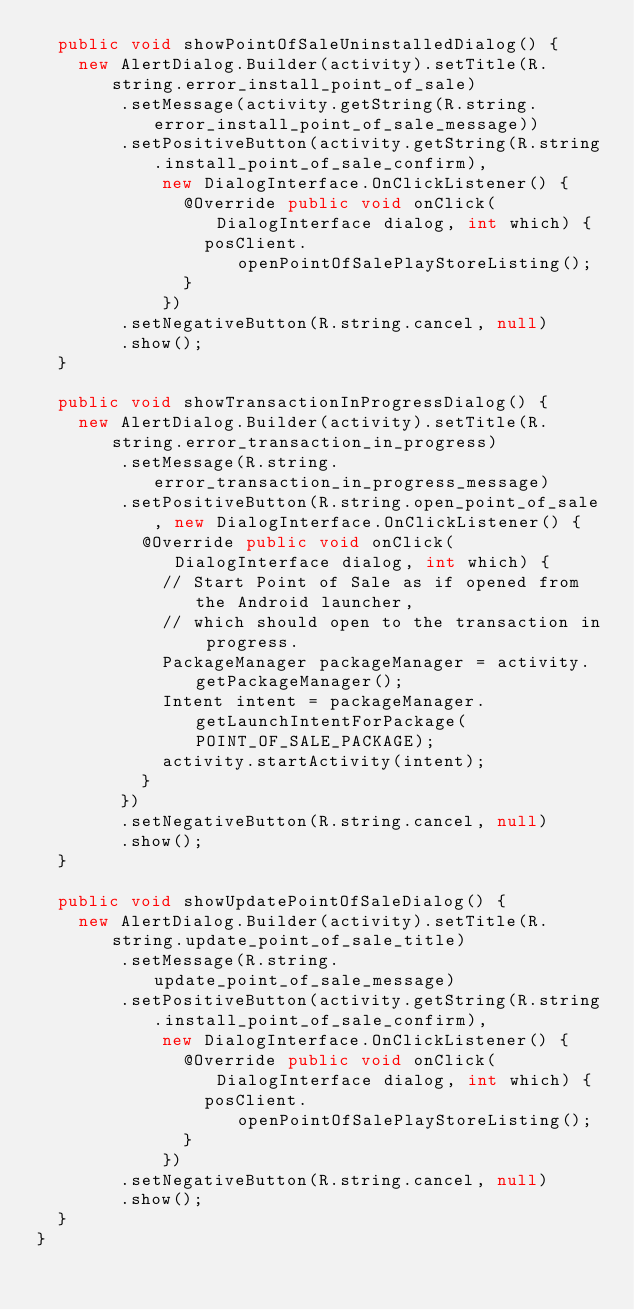Convert code to text. <code><loc_0><loc_0><loc_500><loc_500><_Java_>  public void showPointOfSaleUninstalledDialog() {
    new AlertDialog.Builder(activity).setTitle(R.string.error_install_point_of_sale)
        .setMessage(activity.getString(R.string.error_install_point_of_sale_message))
        .setPositiveButton(activity.getString(R.string.install_point_of_sale_confirm),
            new DialogInterface.OnClickListener() {
              @Override public void onClick(DialogInterface dialog, int which) {
                posClient.openPointOfSalePlayStoreListing();
              }
            })
        .setNegativeButton(R.string.cancel, null)
        .show();
  }

  public void showTransactionInProgressDialog() {
    new AlertDialog.Builder(activity).setTitle(R.string.error_transaction_in_progress)
        .setMessage(R.string.error_transaction_in_progress_message)
        .setPositiveButton(R.string.open_point_of_sale, new DialogInterface.OnClickListener() {
          @Override public void onClick(DialogInterface dialog, int which) {
            // Start Point of Sale as if opened from the Android launcher,
            // which should open to the transaction in progress.
            PackageManager packageManager = activity.getPackageManager();
            Intent intent = packageManager.getLaunchIntentForPackage(POINT_OF_SALE_PACKAGE);
            activity.startActivity(intent);
          }
        })
        .setNegativeButton(R.string.cancel, null)
        .show();
  }

  public void showUpdatePointOfSaleDialog() {
    new AlertDialog.Builder(activity).setTitle(R.string.update_point_of_sale_title)
        .setMessage(R.string.update_point_of_sale_message)
        .setPositiveButton(activity.getString(R.string.install_point_of_sale_confirm),
            new DialogInterface.OnClickListener() {
              @Override public void onClick(DialogInterface dialog, int which) {
                posClient.openPointOfSalePlayStoreListing();
              }
            })
        .setNegativeButton(R.string.cancel, null)
        .show();
  }
}
</code> 